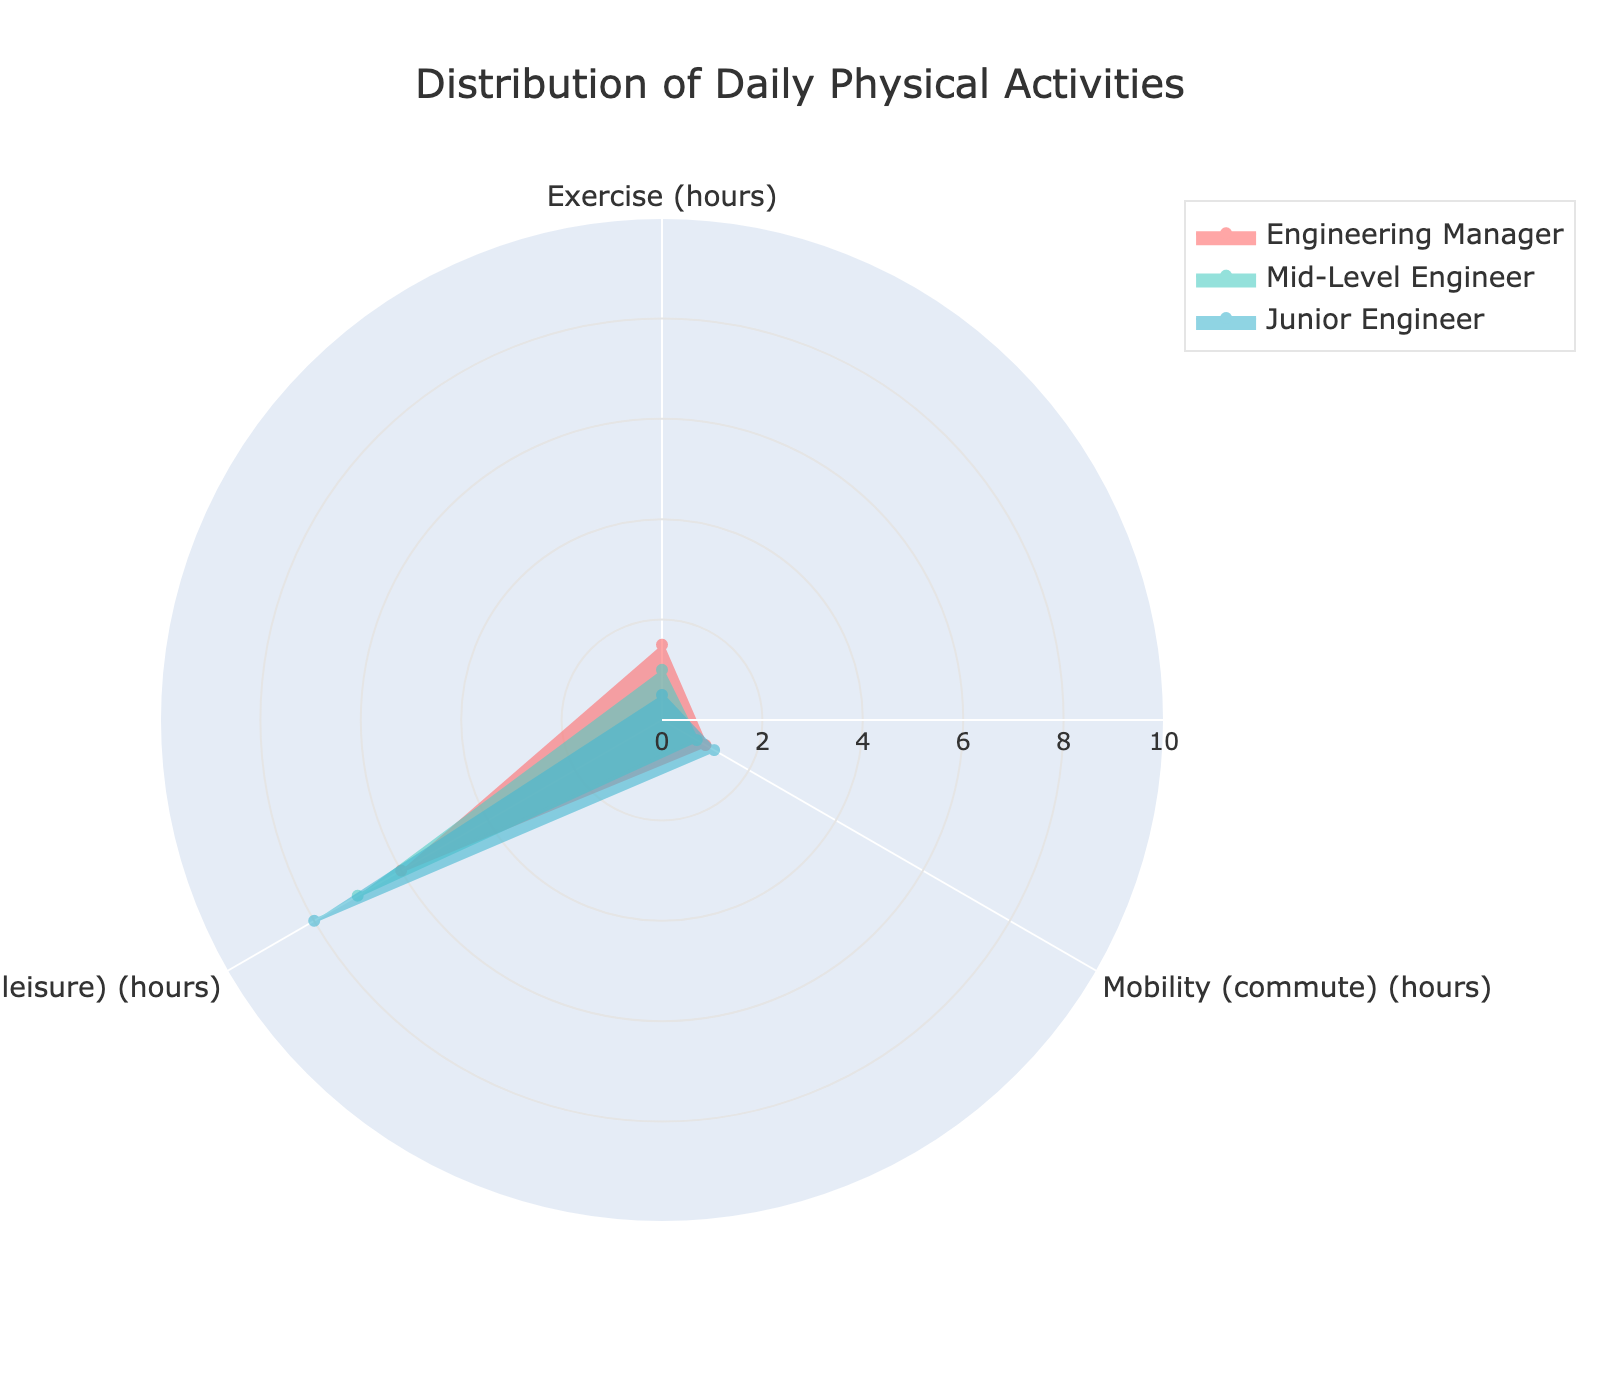What is the title of the radar chart? The title of a chart is typically displayed at the top and provides the main summary of what the chart represents. In this case, it summarises the distribution of physical activities.
Answer: Distribution of Daily Physical Activities Which type of physical activity does the Engineering Manager spend the most time on daily? By looking at the radar chart, the vertex with the highest value for the Engineering Manager would indicate the activity they spend the most time on. In this case, it’s Sedentary Time.
Answer: Sedentary Time How much more time does the Junior Engineer spend on Sedentary Time compared to the Mid-Level Engineer? Find the values for Sedentary Time for both the Junior Engineer (8 hours) and the Mid-Level Engineer (7 hours). Subtract the Mid-Level Engineer's value from the Junior Engineer's value.
Answer: 1 hour Which physical activity has the smallest difference in hours between all three engineers? Compare the values of all physical activities (Exercise, Mobility, Sedentary Time) for the three engineers. The activity with the least variation between them has the smallest difference.
Answer: Mobility Based on the chart, who has the most balanced distribution of daily physical activities? A balanced distribution would look more like an even shape across the radar chart. The Engineering Manager's time distribution appears the most balanced among the three.
Answer: Engineering Manager If you combine the time for Exercise and Mobility for the Mid-Level Engineer, how much time is spent on these activities daily? Add the values for Exercise (1 hour) and Mobility (0.8 hours) in the Mid-Level Engineer's segment of the chart.
Answer: 1.8 hours Who spends the least amount of time commuting daily? The level of Mobility (commute) time that is lowest among the three will indicate who spends the least time commuting.
Answer: Mid-Level Engineer Comparing Exercise and Mobility time, which activity does the Junior Engineer spend more time on? Look at the values for both Exercise (0.5 hours) and Mobility (1.2 hours) for the Junior Engineer and compare them.
Answer: Mobility How much time in total is spent on Sedentary Time by all three engineers combined? Add up the Sedentary Time for the Engineering Manager (6 hours), Mid-Level Engineer (7 hours), and Junior Engineer (8 hours).
Answer: 21 hours Which engineer would need to increase their exercise time the most to match the Engineering Manager's level? Find the difference between the Engineering Manager's Exercise time (1.5 hours) and the Mid-Level Engineer's (1 hour) and Junior Engineer's (0.5 hour). Identify which of the latter has the largest gap.
Answer: Junior Engineer 